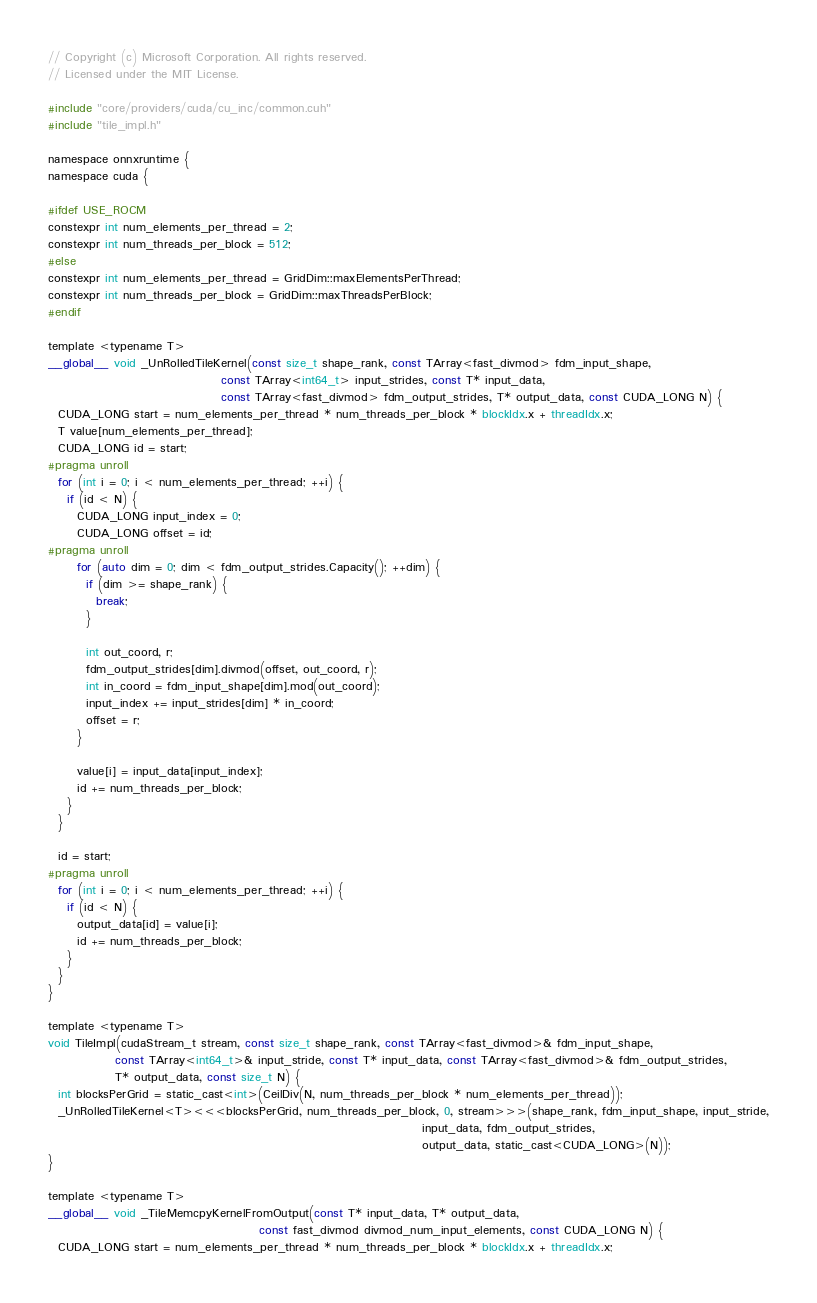Convert code to text. <code><loc_0><loc_0><loc_500><loc_500><_Cuda_>// Copyright (c) Microsoft Corporation. All rights reserved.
// Licensed under the MIT License.

#include "core/providers/cuda/cu_inc/common.cuh"
#include "tile_impl.h"

namespace onnxruntime {
namespace cuda {

#ifdef USE_ROCM
constexpr int num_elements_per_thread = 2;
constexpr int num_threads_per_block = 512;
#else
constexpr int num_elements_per_thread = GridDim::maxElementsPerThread;
constexpr int num_threads_per_block = GridDim::maxThreadsPerBlock;
#endif

template <typename T>
__global__ void _UnRolledTileKernel(const size_t shape_rank, const TArray<fast_divmod> fdm_input_shape,
                                    const TArray<int64_t> input_strides, const T* input_data,
                                    const TArray<fast_divmod> fdm_output_strides, T* output_data, const CUDA_LONG N) {
  CUDA_LONG start = num_elements_per_thread * num_threads_per_block * blockIdx.x + threadIdx.x;
  T value[num_elements_per_thread];
  CUDA_LONG id = start;
#pragma unroll
  for (int i = 0; i < num_elements_per_thread; ++i) {
    if (id < N) {
      CUDA_LONG input_index = 0;
      CUDA_LONG offset = id;
#pragma unroll
      for (auto dim = 0; dim < fdm_output_strides.Capacity(); ++dim) {
        if (dim >= shape_rank) {
          break;
        }

        int out_coord, r;
        fdm_output_strides[dim].divmod(offset, out_coord, r);
        int in_coord = fdm_input_shape[dim].mod(out_coord);
        input_index += input_strides[dim] * in_coord;
        offset = r;
      }

      value[i] = input_data[input_index];
      id += num_threads_per_block;
    }
  }

  id = start;
#pragma unroll
  for (int i = 0; i < num_elements_per_thread; ++i) {
    if (id < N) {
      output_data[id] = value[i];
      id += num_threads_per_block;
    }
  }
}

template <typename T>
void TileImpl(cudaStream_t stream, const size_t shape_rank, const TArray<fast_divmod>& fdm_input_shape,
              const TArray<int64_t>& input_stride, const T* input_data, const TArray<fast_divmod>& fdm_output_strides,
              T* output_data, const size_t N) {
  int blocksPerGrid = static_cast<int>(CeilDiv(N, num_threads_per_block * num_elements_per_thread));
  _UnRolledTileKernel<T><<<blocksPerGrid, num_threads_per_block, 0, stream>>>(shape_rank, fdm_input_shape, input_stride,
                                                                              input_data, fdm_output_strides,
                                                                              output_data, static_cast<CUDA_LONG>(N));
}

template <typename T>
__global__ void _TileMemcpyKernelFromOutput(const T* input_data, T* output_data,
                                            const fast_divmod divmod_num_input_elements, const CUDA_LONG N) {
  CUDA_LONG start = num_elements_per_thread * num_threads_per_block * blockIdx.x + threadIdx.x;</code> 